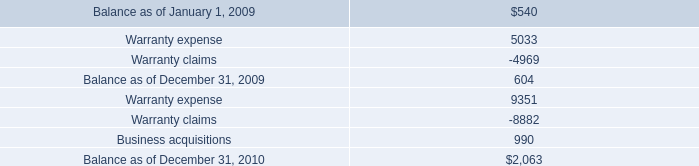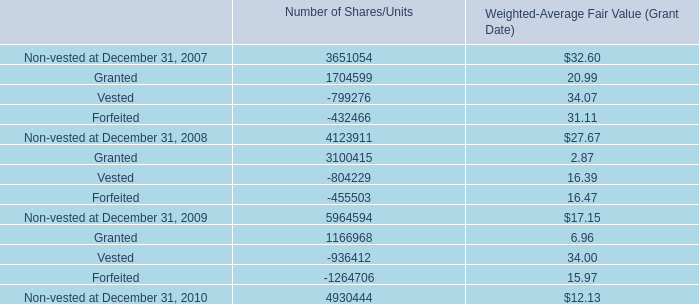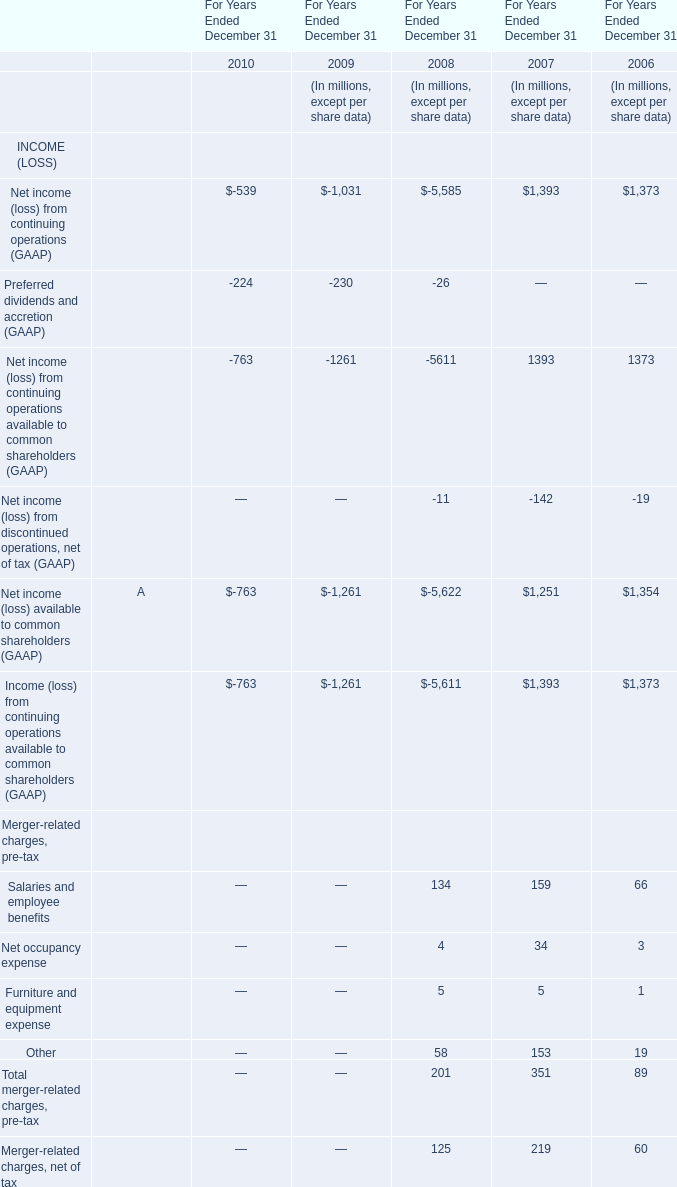If Cash provided by operating activities develops with the same growth rate in 2007, what will it reach in 2008? (in million) 
Computations: ((1 + ((351 - 89) / 89)) * 351)
Answer: 1384.2809. 